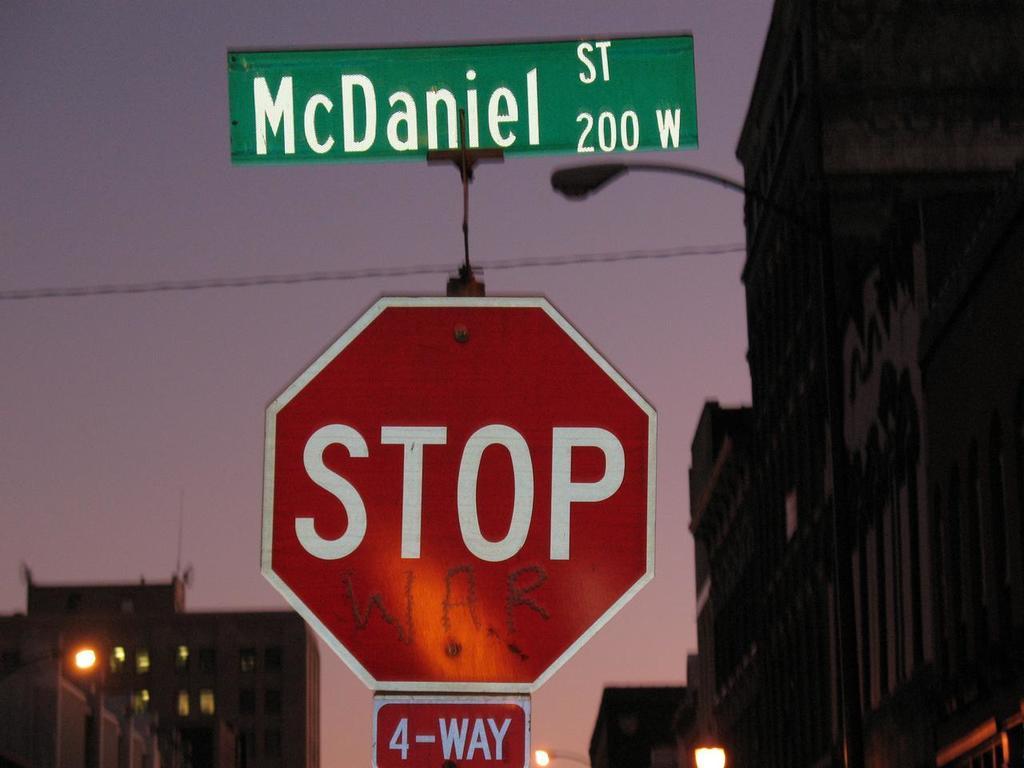How many ways is the stop sign?
Keep it short and to the point. 4. What street is this stop sign at?
Ensure brevity in your answer.  Mcdaniel. 